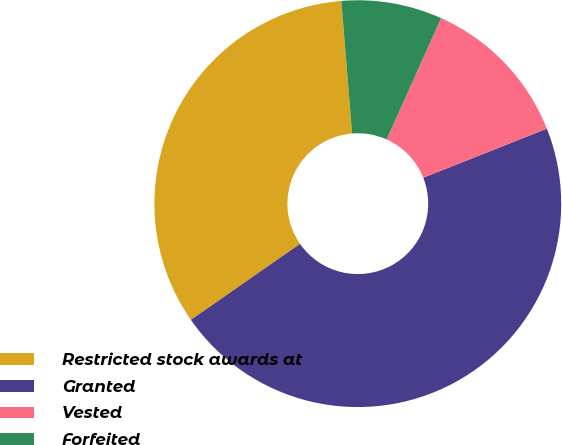<chart> <loc_0><loc_0><loc_500><loc_500><pie_chart><fcel>Restricted stock awards at<fcel>Granted<fcel>Vested<fcel>Forfeited<nl><fcel>33.39%<fcel>46.33%<fcel>12.27%<fcel>8.01%<nl></chart> 